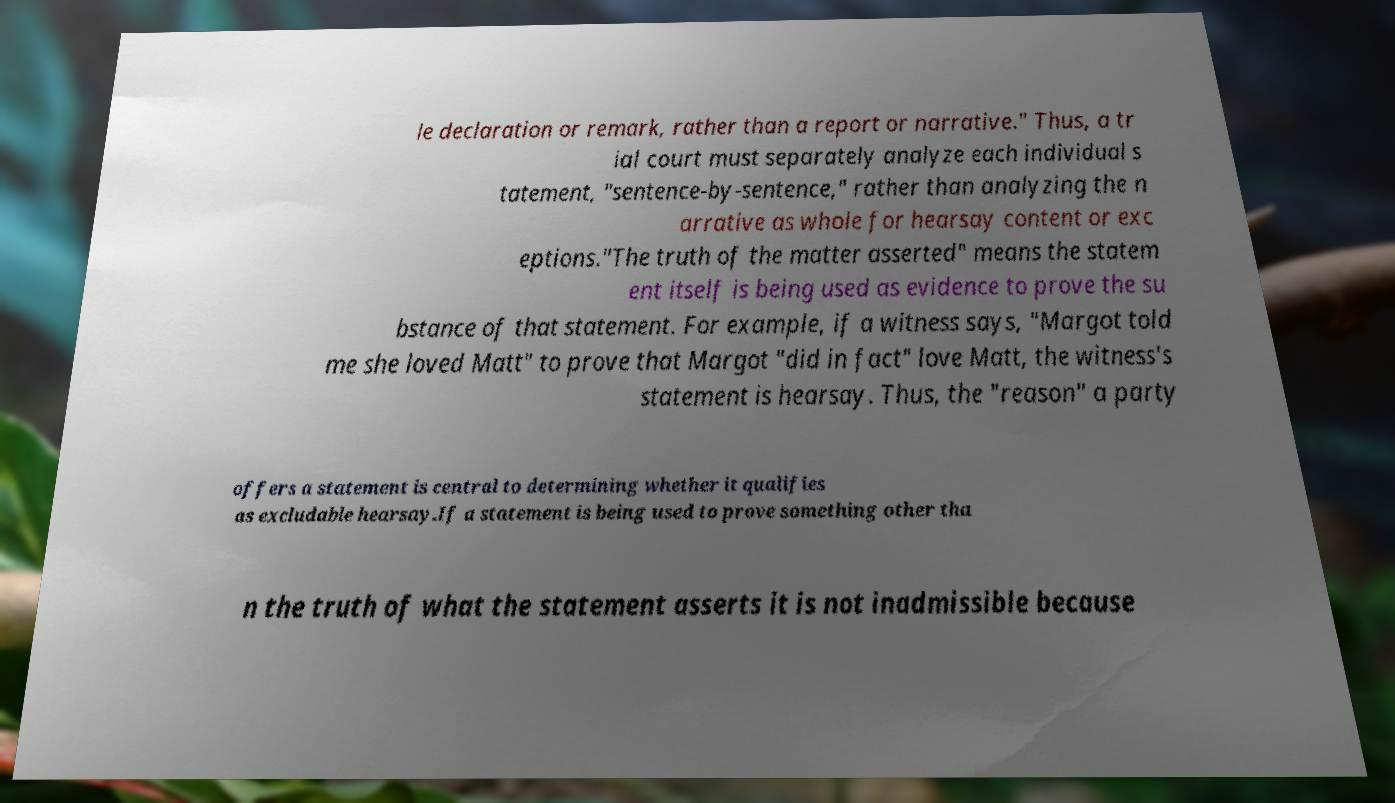Can you read and provide the text displayed in the image?This photo seems to have some interesting text. Can you extract and type it out for me? le declaration or remark, rather than a report or narrative." Thus, a tr ial court must separately analyze each individual s tatement, "sentence-by-sentence," rather than analyzing the n arrative as whole for hearsay content or exc eptions."The truth of the matter asserted" means the statem ent itself is being used as evidence to prove the su bstance of that statement. For example, if a witness says, "Margot told me she loved Matt" to prove that Margot "did in fact" love Matt, the witness's statement is hearsay. Thus, the "reason" a party offers a statement is central to determining whether it qualifies as excludable hearsay.If a statement is being used to prove something other tha n the truth of what the statement asserts it is not inadmissible because 